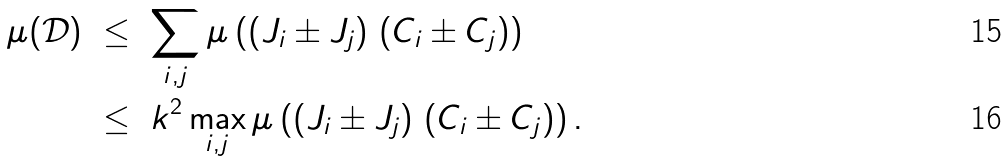<formula> <loc_0><loc_0><loc_500><loc_500>\mu ( \mathcal { D } ) & \ \leq \ \sum _ { i , j } \mu \left ( ( J _ { i } \pm J _ { j } ) \ ( C _ { i } \pm C _ { j } ) \right ) \\ & \ \leq \ k ^ { 2 } \max _ { i , j } \mu \left ( ( J _ { i } \pm J _ { j } ) \ ( C _ { i } \pm C _ { j } ) \right ) .</formula> 